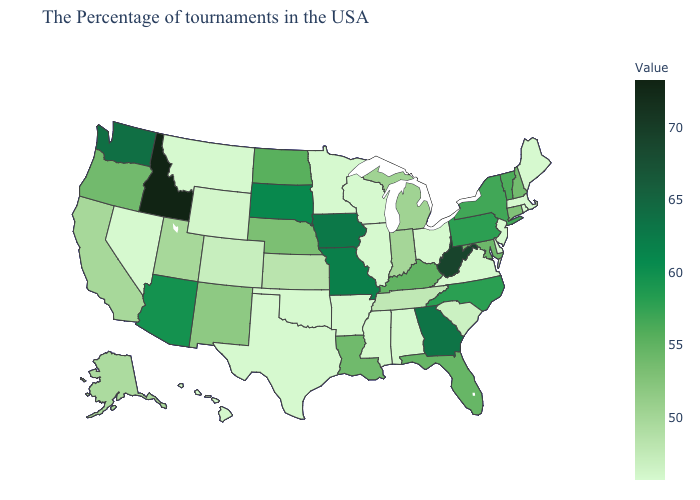Does Idaho have the highest value in the USA?
Write a very short answer. Yes. Does New Hampshire have a higher value than New York?
Quick response, please. No. Does West Virginia have the highest value in the South?
Short answer required. Yes. Does Rhode Island have the lowest value in the USA?
Give a very brief answer. Yes. Does Oregon have a lower value than Kansas?
Quick response, please. No. 